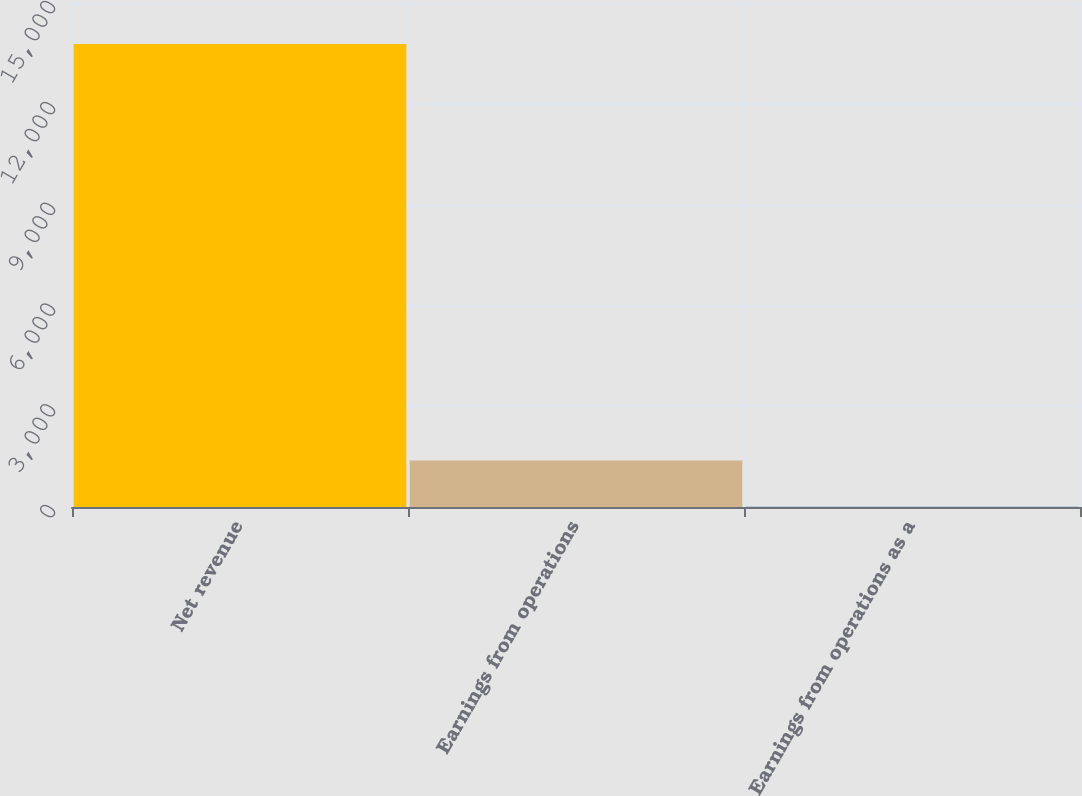Convert chart to OTSL. <chart><loc_0><loc_0><loc_500><loc_500><bar_chart><fcel>Net revenue<fcel>Earnings from operations<fcel>Earnings from operations as a<nl><fcel>13778<fcel>1386.08<fcel>9.2<nl></chart> 